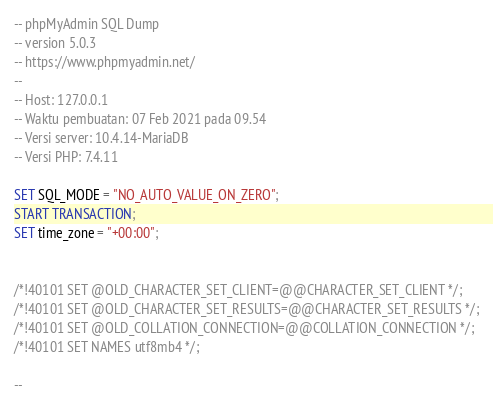Convert code to text. <code><loc_0><loc_0><loc_500><loc_500><_SQL_>-- phpMyAdmin SQL Dump
-- version 5.0.3
-- https://www.phpmyadmin.net/
--
-- Host: 127.0.0.1
-- Waktu pembuatan: 07 Feb 2021 pada 09.54
-- Versi server: 10.4.14-MariaDB
-- Versi PHP: 7.4.11

SET SQL_MODE = "NO_AUTO_VALUE_ON_ZERO";
START TRANSACTION;
SET time_zone = "+00:00";


/*!40101 SET @OLD_CHARACTER_SET_CLIENT=@@CHARACTER_SET_CLIENT */;
/*!40101 SET @OLD_CHARACTER_SET_RESULTS=@@CHARACTER_SET_RESULTS */;
/*!40101 SET @OLD_COLLATION_CONNECTION=@@COLLATION_CONNECTION */;
/*!40101 SET NAMES utf8mb4 */;

--</code> 